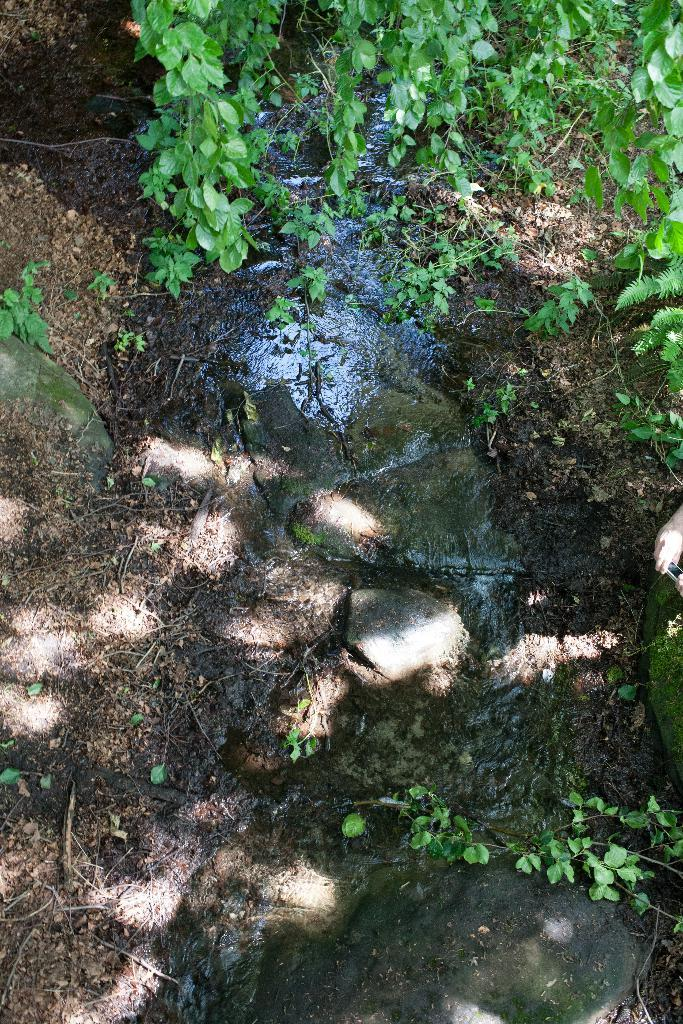What type of vegetation is visible at the top of the image? There are trees at the top of the image. What is the main feature in the center of the image? There is a small canal in the center of the image. What materials and objects can be seen on the left side of the image? There are stones, plants, and soil on the left side of the image. What materials are present on the right side of the image? There are stones and soil on the right side of the image. What type of education can be seen taking place near the canal in the image? There is no education or educational activity visible in the image. How many bushes are present on the left side of the image? There is no mention of bushes in the provided facts, so we cannot determine their presence or quantity. 